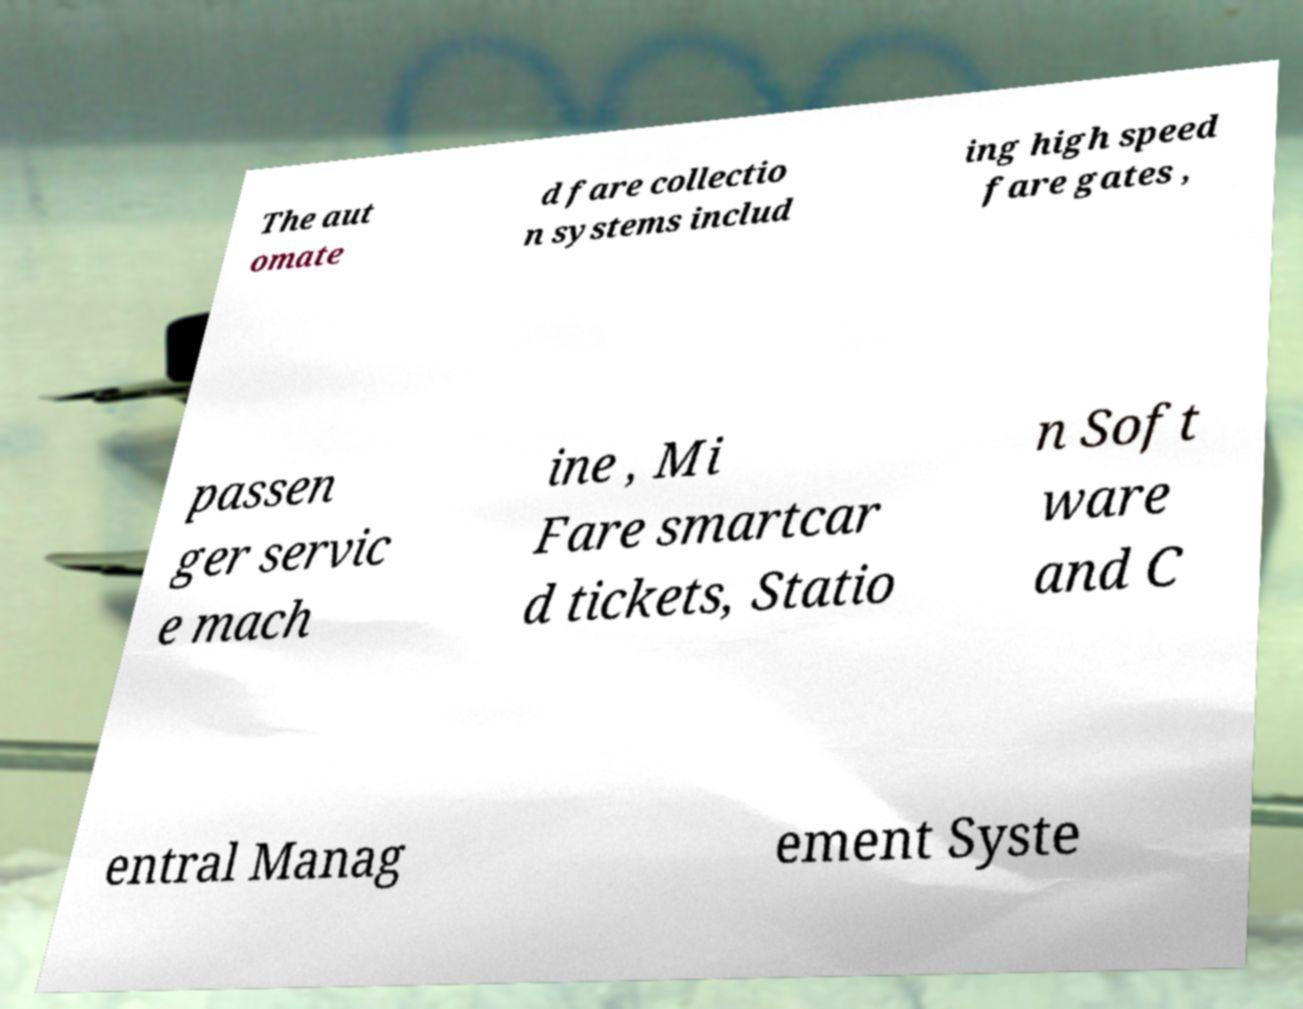Could you extract and type out the text from this image? The aut omate d fare collectio n systems includ ing high speed fare gates , passen ger servic e mach ine , Mi Fare smartcar d tickets, Statio n Soft ware and C entral Manag ement Syste 